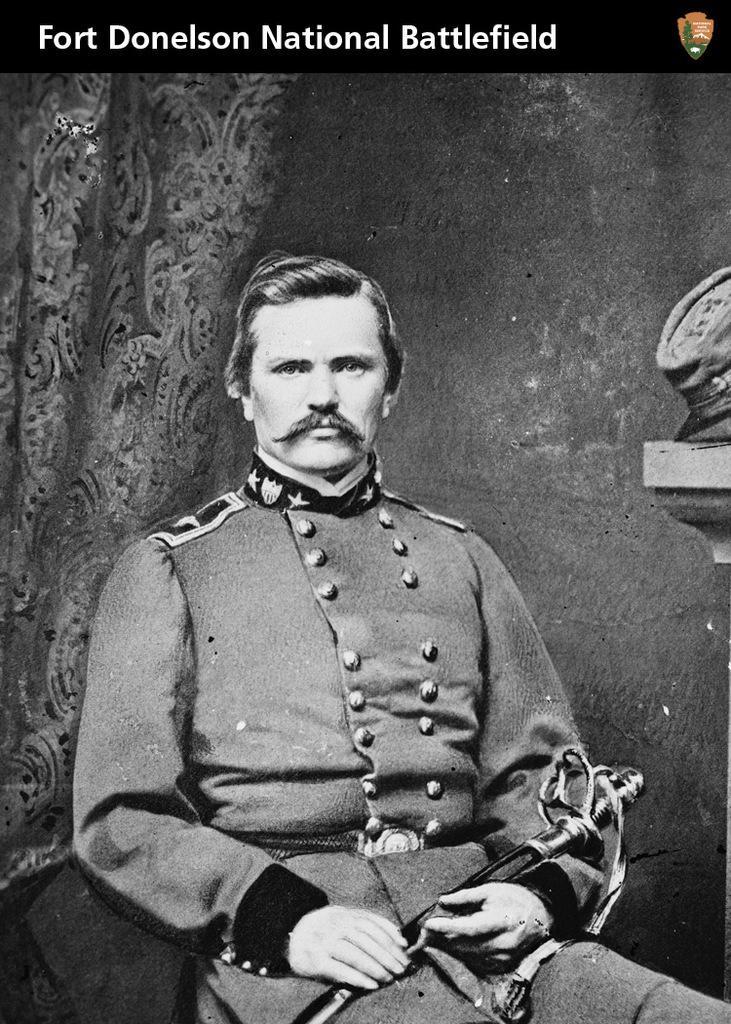Can you describe this image briefly? In this picture we can see a man who is sitting and hold a knife in his hands. And he wear a uniform. 